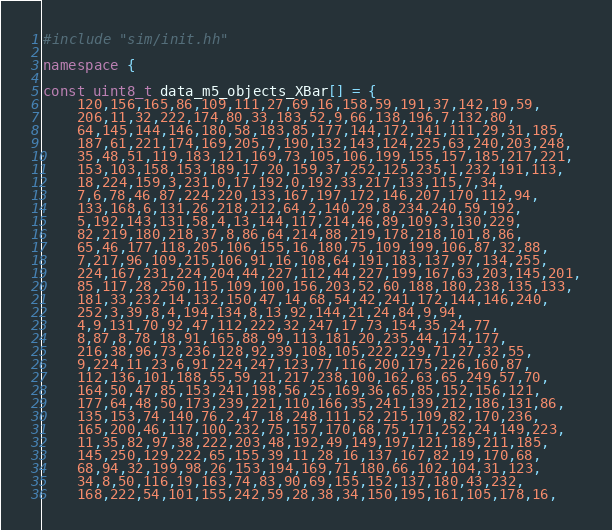<code> <loc_0><loc_0><loc_500><loc_500><_C++_>#include "sim/init.hh"

namespace {

const uint8_t data_m5_objects_XBar[] = {
    120,156,165,86,109,111,27,69,16,158,59,191,37,142,19,59,
    206,11,32,222,174,80,33,183,52,9,66,138,196,7,132,80,
    64,145,144,146,180,58,183,85,177,144,172,141,111,29,31,185,
    187,61,221,174,169,205,7,190,132,143,124,225,63,240,203,248,
    35,48,51,119,183,121,169,73,105,106,199,155,157,185,217,221,
    153,103,158,153,189,17,20,159,37,252,125,235,1,232,191,113,
    18,224,159,3,231,0,17,192,0,192,33,217,133,115,7,34,
    7,6,78,46,87,224,220,133,167,197,172,146,207,170,112,94,
    133,168,6,131,26,218,212,64,2,140,29,8,234,240,59,192,
    5,192,143,131,58,4,13,144,117,214,46,89,109,3,130,229,
    82,219,180,218,37,8,86,64,214,88,219,178,218,101,8,86,
    65,46,177,118,205,106,155,16,180,75,109,199,106,87,32,88,
    7,217,96,109,215,106,91,16,108,64,191,183,137,97,134,255,
    224,167,231,224,204,44,227,112,44,227,199,167,63,203,145,201,
    85,117,28,250,115,109,100,156,203,52,60,188,180,238,135,133,
    181,33,232,14,132,150,47,14,68,54,42,241,172,144,146,240,
    252,3,39,8,4,194,134,8,13,92,144,21,24,84,9,94,
    4,9,131,70,92,47,112,222,32,247,17,73,154,35,24,77,
    8,87,8,78,18,91,165,88,99,113,181,20,235,44,174,177,
    216,38,96,73,236,128,92,39,108,105,222,229,71,27,32,55,
    9,224,11,23,6,91,224,247,123,77,116,200,175,226,160,87,
    112,136,101,188,55,59,21,217,238,100,162,63,65,249,57,70,
    164,50,47,85,153,241,198,56,25,169,36,65,85,152,156,121,
    177,64,48,50,173,239,221,110,166,35,241,139,212,186,131,86,
    135,153,74,140,76,2,47,18,248,111,52,215,109,82,170,236,
    165,200,46,117,100,232,75,157,170,68,75,171,252,24,149,223,
    11,35,82,97,38,222,203,48,192,49,149,197,121,189,211,185,
    145,250,129,222,65,155,39,11,28,16,137,167,82,19,170,68,
    68,94,32,199,98,26,153,194,169,71,180,66,102,104,31,123,
    34,8,50,116,19,163,74,83,90,69,155,152,137,180,43,232,
    168,222,54,101,155,242,59,28,38,34,150,195,161,105,178,16,</code> 